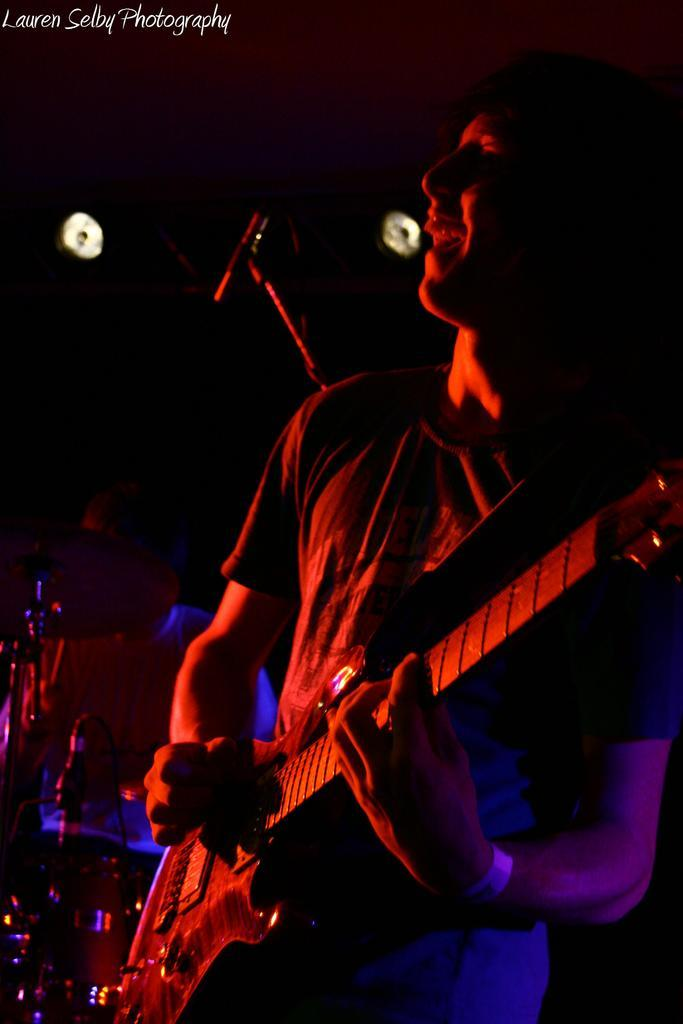What is the man in the image doing? The man is playing a guitar in the image. What expression does the man have? The man is smiling in the image. What object is behind the man? There is a microphone behind the man in the image. What instrument is being played by the person in the background? The person in the background is playing drums. What can be seen at the top of the image? There are lights visible at the top of the image. What book is the man reading while playing the guitar? There is no book present in the image; the man is playing the guitar and smiling. 